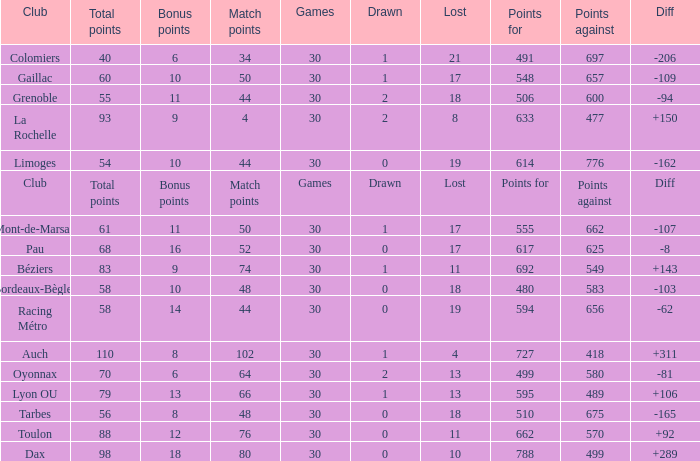What is the amount of match points for a club that lost 18 and has 11 bonus points? 44.0. 